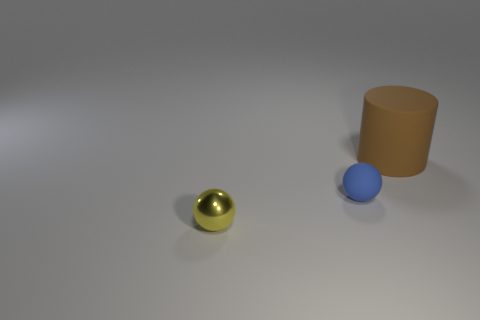Subtract all spheres. How many objects are left? 1 Add 1 large brown cylinders. How many objects exist? 4 Subtract all purple balls. How many green cylinders are left? 0 Subtract all blue rubber objects. Subtract all brown matte blocks. How many objects are left? 2 Add 1 metallic things. How many metallic things are left? 2 Add 1 big brown things. How many big brown things exist? 2 Subtract 0 blue cylinders. How many objects are left? 3 Subtract 1 cylinders. How many cylinders are left? 0 Subtract all gray spheres. Subtract all brown blocks. How many spheres are left? 2 